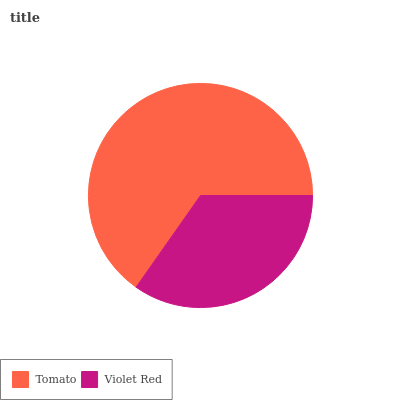Is Violet Red the minimum?
Answer yes or no. Yes. Is Tomato the maximum?
Answer yes or no. Yes. Is Violet Red the maximum?
Answer yes or no. No. Is Tomato greater than Violet Red?
Answer yes or no. Yes. Is Violet Red less than Tomato?
Answer yes or no. Yes. Is Violet Red greater than Tomato?
Answer yes or no. No. Is Tomato less than Violet Red?
Answer yes or no. No. Is Tomato the high median?
Answer yes or no. Yes. Is Violet Red the low median?
Answer yes or no. Yes. Is Violet Red the high median?
Answer yes or no. No. Is Tomato the low median?
Answer yes or no. No. 